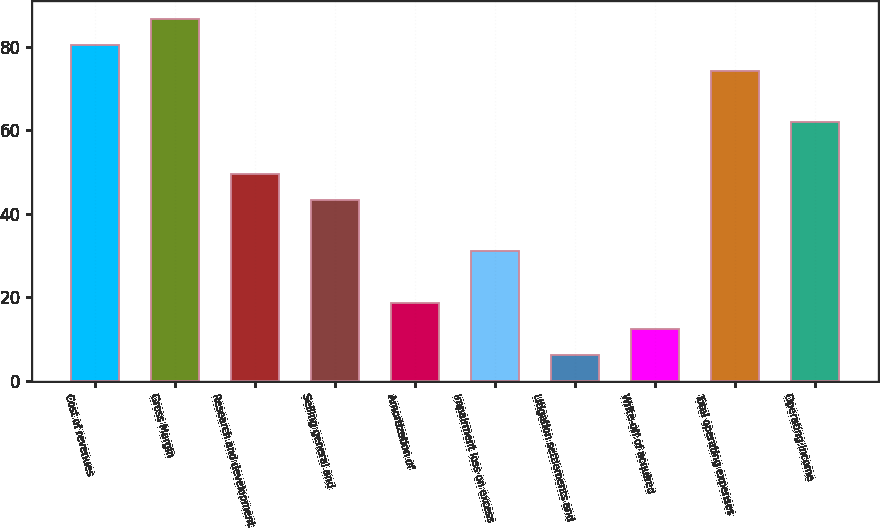<chart> <loc_0><loc_0><loc_500><loc_500><bar_chart><fcel>Cost of revenues<fcel>Gross Margin<fcel>Research and development<fcel>Selling general and<fcel>Amortization of<fcel>Impairment loss on excess<fcel>Litigation settlements and<fcel>Write-off of acquired<fcel>Total operating expenses<fcel>Operating Income<nl><fcel>80.44<fcel>86.62<fcel>49.54<fcel>43.36<fcel>18.64<fcel>31<fcel>6.28<fcel>12.46<fcel>74.26<fcel>61.9<nl></chart> 